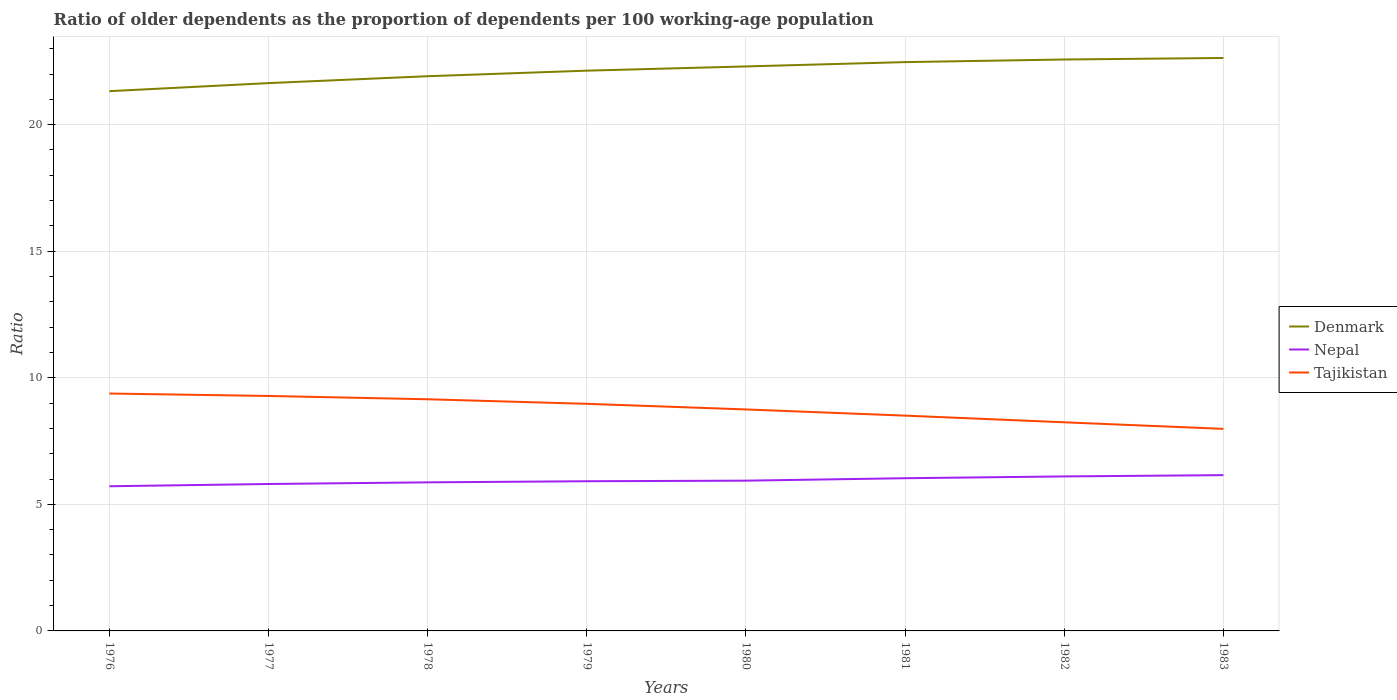How many different coloured lines are there?
Your answer should be very brief. 3. Across all years, what is the maximum age dependency ratio(old) in Denmark?
Give a very brief answer. 21.32. In which year was the age dependency ratio(old) in Nepal maximum?
Give a very brief answer. 1976. What is the total age dependency ratio(old) in Nepal in the graph?
Make the answer very short. -0.24. What is the difference between the highest and the second highest age dependency ratio(old) in Nepal?
Keep it short and to the point. 0.44. What is the difference between the highest and the lowest age dependency ratio(old) in Denmark?
Provide a short and direct response. 5. What is the difference between two consecutive major ticks on the Y-axis?
Make the answer very short. 5. Does the graph contain any zero values?
Your answer should be compact. No. Does the graph contain grids?
Keep it short and to the point. Yes. How many legend labels are there?
Your answer should be compact. 3. How are the legend labels stacked?
Provide a short and direct response. Vertical. What is the title of the graph?
Make the answer very short. Ratio of older dependents as the proportion of dependents per 100 working-age population. What is the label or title of the X-axis?
Offer a very short reply. Years. What is the label or title of the Y-axis?
Offer a very short reply. Ratio. What is the Ratio in Denmark in 1976?
Your answer should be very brief. 21.32. What is the Ratio in Nepal in 1976?
Offer a terse response. 5.72. What is the Ratio of Tajikistan in 1976?
Make the answer very short. 9.38. What is the Ratio of Denmark in 1977?
Ensure brevity in your answer.  21.64. What is the Ratio in Nepal in 1977?
Your answer should be compact. 5.8. What is the Ratio in Tajikistan in 1977?
Provide a short and direct response. 9.28. What is the Ratio in Denmark in 1978?
Provide a short and direct response. 21.91. What is the Ratio of Nepal in 1978?
Ensure brevity in your answer.  5.87. What is the Ratio of Tajikistan in 1978?
Make the answer very short. 9.15. What is the Ratio of Denmark in 1979?
Your response must be concise. 22.13. What is the Ratio of Nepal in 1979?
Give a very brief answer. 5.91. What is the Ratio in Tajikistan in 1979?
Provide a succinct answer. 8.97. What is the Ratio of Denmark in 1980?
Make the answer very short. 22.3. What is the Ratio of Nepal in 1980?
Make the answer very short. 5.94. What is the Ratio of Tajikistan in 1980?
Give a very brief answer. 8.75. What is the Ratio of Denmark in 1981?
Provide a short and direct response. 22.47. What is the Ratio of Nepal in 1981?
Ensure brevity in your answer.  6.03. What is the Ratio of Tajikistan in 1981?
Offer a terse response. 8.51. What is the Ratio of Denmark in 1982?
Provide a short and direct response. 22.57. What is the Ratio of Nepal in 1982?
Your answer should be compact. 6.1. What is the Ratio in Tajikistan in 1982?
Keep it short and to the point. 8.24. What is the Ratio in Denmark in 1983?
Make the answer very short. 22.63. What is the Ratio in Nepal in 1983?
Your response must be concise. 6.15. What is the Ratio in Tajikistan in 1983?
Offer a terse response. 7.98. Across all years, what is the maximum Ratio of Denmark?
Provide a succinct answer. 22.63. Across all years, what is the maximum Ratio in Nepal?
Give a very brief answer. 6.15. Across all years, what is the maximum Ratio in Tajikistan?
Offer a very short reply. 9.38. Across all years, what is the minimum Ratio in Denmark?
Offer a terse response. 21.32. Across all years, what is the minimum Ratio of Nepal?
Offer a very short reply. 5.72. Across all years, what is the minimum Ratio in Tajikistan?
Ensure brevity in your answer.  7.98. What is the total Ratio in Denmark in the graph?
Your answer should be compact. 176.99. What is the total Ratio in Nepal in the graph?
Keep it short and to the point. 47.53. What is the total Ratio in Tajikistan in the graph?
Make the answer very short. 70.26. What is the difference between the Ratio in Denmark in 1976 and that in 1977?
Give a very brief answer. -0.32. What is the difference between the Ratio in Nepal in 1976 and that in 1977?
Keep it short and to the point. -0.09. What is the difference between the Ratio of Tajikistan in 1976 and that in 1977?
Make the answer very short. 0.1. What is the difference between the Ratio of Denmark in 1976 and that in 1978?
Provide a succinct answer. -0.59. What is the difference between the Ratio in Nepal in 1976 and that in 1978?
Your answer should be very brief. -0.15. What is the difference between the Ratio in Tajikistan in 1976 and that in 1978?
Provide a short and direct response. 0.23. What is the difference between the Ratio in Denmark in 1976 and that in 1979?
Give a very brief answer. -0.81. What is the difference between the Ratio of Nepal in 1976 and that in 1979?
Offer a terse response. -0.2. What is the difference between the Ratio of Tajikistan in 1976 and that in 1979?
Offer a terse response. 0.41. What is the difference between the Ratio of Denmark in 1976 and that in 1980?
Keep it short and to the point. -0.98. What is the difference between the Ratio in Nepal in 1976 and that in 1980?
Give a very brief answer. -0.22. What is the difference between the Ratio in Tajikistan in 1976 and that in 1980?
Make the answer very short. 0.63. What is the difference between the Ratio in Denmark in 1976 and that in 1981?
Your answer should be very brief. -1.15. What is the difference between the Ratio of Nepal in 1976 and that in 1981?
Give a very brief answer. -0.32. What is the difference between the Ratio of Tajikistan in 1976 and that in 1981?
Provide a succinct answer. 0.87. What is the difference between the Ratio of Denmark in 1976 and that in 1982?
Your answer should be very brief. -1.25. What is the difference between the Ratio in Nepal in 1976 and that in 1982?
Provide a succinct answer. -0.39. What is the difference between the Ratio in Tajikistan in 1976 and that in 1982?
Provide a short and direct response. 1.14. What is the difference between the Ratio of Denmark in 1976 and that in 1983?
Your answer should be very brief. -1.31. What is the difference between the Ratio of Nepal in 1976 and that in 1983?
Ensure brevity in your answer.  -0.44. What is the difference between the Ratio of Tajikistan in 1976 and that in 1983?
Provide a short and direct response. 1.4. What is the difference between the Ratio of Denmark in 1977 and that in 1978?
Provide a succinct answer. -0.27. What is the difference between the Ratio in Nepal in 1977 and that in 1978?
Your answer should be very brief. -0.07. What is the difference between the Ratio in Tajikistan in 1977 and that in 1978?
Your answer should be very brief. 0.13. What is the difference between the Ratio in Denmark in 1977 and that in 1979?
Keep it short and to the point. -0.49. What is the difference between the Ratio of Nepal in 1977 and that in 1979?
Provide a succinct answer. -0.11. What is the difference between the Ratio of Tajikistan in 1977 and that in 1979?
Your answer should be compact. 0.31. What is the difference between the Ratio of Denmark in 1977 and that in 1980?
Provide a succinct answer. -0.66. What is the difference between the Ratio of Nepal in 1977 and that in 1980?
Your answer should be compact. -0.13. What is the difference between the Ratio of Tajikistan in 1977 and that in 1980?
Offer a very short reply. 0.53. What is the difference between the Ratio of Denmark in 1977 and that in 1981?
Offer a very short reply. -0.83. What is the difference between the Ratio of Nepal in 1977 and that in 1981?
Give a very brief answer. -0.23. What is the difference between the Ratio of Tajikistan in 1977 and that in 1981?
Ensure brevity in your answer.  0.78. What is the difference between the Ratio of Denmark in 1977 and that in 1982?
Your answer should be very brief. -0.93. What is the difference between the Ratio of Nepal in 1977 and that in 1982?
Provide a short and direct response. -0.3. What is the difference between the Ratio of Tajikistan in 1977 and that in 1982?
Your answer should be very brief. 1.04. What is the difference between the Ratio in Denmark in 1977 and that in 1983?
Provide a succinct answer. -0.99. What is the difference between the Ratio in Nepal in 1977 and that in 1983?
Give a very brief answer. -0.35. What is the difference between the Ratio in Tajikistan in 1977 and that in 1983?
Provide a succinct answer. 1.3. What is the difference between the Ratio in Denmark in 1978 and that in 1979?
Make the answer very short. -0.22. What is the difference between the Ratio of Nepal in 1978 and that in 1979?
Your response must be concise. -0.04. What is the difference between the Ratio in Tajikistan in 1978 and that in 1979?
Provide a succinct answer. 0.18. What is the difference between the Ratio in Denmark in 1978 and that in 1980?
Give a very brief answer. -0.39. What is the difference between the Ratio of Nepal in 1978 and that in 1980?
Provide a short and direct response. -0.07. What is the difference between the Ratio in Tajikistan in 1978 and that in 1980?
Provide a succinct answer. 0.4. What is the difference between the Ratio in Denmark in 1978 and that in 1981?
Keep it short and to the point. -0.56. What is the difference between the Ratio in Nepal in 1978 and that in 1981?
Keep it short and to the point. -0.16. What is the difference between the Ratio of Tajikistan in 1978 and that in 1981?
Make the answer very short. 0.65. What is the difference between the Ratio of Denmark in 1978 and that in 1982?
Ensure brevity in your answer.  -0.66. What is the difference between the Ratio in Nepal in 1978 and that in 1982?
Your answer should be very brief. -0.23. What is the difference between the Ratio of Tajikistan in 1978 and that in 1982?
Ensure brevity in your answer.  0.91. What is the difference between the Ratio in Denmark in 1978 and that in 1983?
Your answer should be compact. -0.72. What is the difference between the Ratio of Nepal in 1978 and that in 1983?
Keep it short and to the point. -0.28. What is the difference between the Ratio in Tajikistan in 1978 and that in 1983?
Provide a short and direct response. 1.17. What is the difference between the Ratio in Denmark in 1979 and that in 1980?
Give a very brief answer. -0.17. What is the difference between the Ratio in Nepal in 1979 and that in 1980?
Ensure brevity in your answer.  -0.02. What is the difference between the Ratio of Tajikistan in 1979 and that in 1980?
Offer a very short reply. 0.22. What is the difference between the Ratio in Denmark in 1979 and that in 1981?
Give a very brief answer. -0.34. What is the difference between the Ratio of Nepal in 1979 and that in 1981?
Your response must be concise. -0.12. What is the difference between the Ratio in Tajikistan in 1979 and that in 1981?
Offer a terse response. 0.47. What is the difference between the Ratio of Denmark in 1979 and that in 1982?
Offer a very short reply. -0.44. What is the difference between the Ratio in Nepal in 1979 and that in 1982?
Ensure brevity in your answer.  -0.19. What is the difference between the Ratio in Tajikistan in 1979 and that in 1982?
Offer a very short reply. 0.73. What is the difference between the Ratio of Denmark in 1979 and that in 1983?
Your answer should be very brief. -0.5. What is the difference between the Ratio of Nepal in 1979 and that in 1983?
Provide a short and direct response. -0.24. What is the difference between the Ratio of Tajikistan in 1979 and that in 1983?
Ensure brevity in your answer.  0.99. What is the difference between the Ratio of Denmark in 1980 and that in 1981?
Your response must be concise. -0.17. What is the difference between the Ratio in Nepal in 1980 and that in 1981?
Provide a succinct answer. -0.1. What is the difference between the Ratio in Tajikistan in 1980 and that in 1981?
Provide a short and direct response. 0.24. What is the difference between the Ratio of Denmark in 1980 and that in 1982?
Provide a succinct answer. -0.27. What is the difference between the Ratio of Nepal in 1980 and that in 1982?
Your response must be concise. -0.17. What is the difference between the Ratio of Tajikistan in 1980 and that in 1982?
Ensure brevity in your answer.  0.51. What is the difference between the Ratio in Denmark in 1980 and that in 1983?
Your response must be concise. -0.33. What is the difference between the Ratio in Nepal in 1980 and that in 1983?
Your answer should be very brief. -0.22. What is the difference between the Ratio of Tajikistan in 1980 and that in 1983?
Offer a very short reply. 0.77. What is the difference between the Ratio of Denmark in 1981 and that in 1982?
Provide a succinct answer. -0.1. What is the difference between the Ratio in Nepal in 1981 and that in 1982?
Make the answer very short. -0.07. What is the difference between the Ratio in Tajikistan in 1981 and that in 1982?
Ensure brevity in your answer.  0.26. What is the difference between the Ratio in Denmark in 1981 and that in 1983?
Keep it short and to the point. -0.16. What is the difference between the Ratio in Nepal in 1981 and that in 1983?
Provide a succinct answer. -0.12. What is the difference between the Ratio in Tajikistan in 1981 and that in 1983?
Provide a short and direct response. 0.52. What is the difference between the Ratio of Denmark in 1982 and that in 1983?
Provide a short and direct response. -0.06. What is the difference between the Ratio of Nepal in 1982 and that in 1983?
Make the answer very short. -0.05. What is the difference between the Ratio in Tajikistan in 1982 and that in 1983?
Your answer should be very brief. 0.26. What is the difference between the Ratio of Denmark in 1976 and the Ratio of Nepal in 1977?
Give a very brief answer. 15.52. What is the difference between the Ratio of Denmark in 1976 and the Ratio of Tajikistan in 1977?
Ensure brevity in your answer.  12.04. What is the difference between the Ratio of Nepal in 1976 and the Ratio of Tajikistan in 1977?
Provide a succinct answer. -3.57. What is the difference between the Ratio in Denmark in 1976 and the Ratio in Nepal in 1978?
Give a very brief answer. 15.45. What is the difference between the Ratio of Denmark in 1976 and the Ratio of Tajikistan in 1978?
Offer a very short reply. 12.17. What is the difference between the Ratio of Nepal in 1976 and the Ratio of Tajikistan in 1978?
Your answer should be compact. -3.44. What is the difference between the Ratio in Denmark in 1976 and the Ratio in Nepal in 1979?
Keep it short and to the point. 15.41. What is the difference between the Ratio of Denmark in 1976 and the Ratio of Tajikistan in 1979?
Your answer should be very brief. 12.35. What is the difference between the Ratio of Nepal in 1976 and the Ratio of Tajikistan in 1979?
Keep it short and to the point. -3.26. What is the difference between the Ratio in Denmark in 1976 and the Ratio in Nepal in 1980?
Your response must be concise. 15.39. What is the difference between the Ratio in Denmark in 1976 and the Ratio in Tajikistan in 1980?
Your response must be concise. 12.57. What is the difference between the Ratio of Nepal in 1976 and the Ratio of Tajikistan in 1980?
Keep it short and to the point. -3.03. What is the difference between the Ratio of Denmark in 1976 and the Ratio of Nepal in 1981?
Make the answer very short. 15.29. What is the difference between the Ratio in Denmark in 1976 and the Ratio in Tajikistan in 1981?
Keep it short and to the point. 12.82. What is the difference between the Ratio of Nepal in 1976 and the Ratio of Tajikistan in 1981?
Give a very brief answer. -2.79. What is the difference between the Ratio of Denmark in 1976 and the Ratio of Nepal in 1982?
Give a very brief answer. 15.22. What is the difference between the Ratio in Denmark in 1976 and the Ratio in Tajikistan in 1982?
Make the answer very short. 13.08. What is the difference between the Ratio of Nepal in 1976 and the Ratio of Tajikistan in 1982?
Provide a short and direct response. -2.53. What is the difference between the Ratio in Denmark in 1976 and the Ratio in Nepal in 1983?
Your answer should be compact. 15.17. What is the difference between the Ratio of Denmark in 1976 and the Ratio of Tajikistan in 1983?
Your answer should be very brief. 13.34. What is the difference between the Ratio of Nepal in 1976 and the Ratio of Tajikistan in 1983?
Offer a terse response. -2.27. What is the difference between the Ratio of Denmark in 1977 and the Ratio of Nepal in 1978?
Your response must be concise. 15.77. What is the difference between the Ratio of Denmark in 1977 and the Ratio of Tajikistan in 1978?
Keep it short and to the point. 12.49. What is the difference between the Ratio of Nepal in 1977 and the Ratio of Tajikistan in 1978?
Offer a very short reply. -3.35. What is the difference between the Ratio in Denmark in 1977 and the Ratio in Nepal in 1979?
Your answer should be very brief. 15.73. What is the difference between the Ratio in Denmark in 1977 and the Ratio in Tajikistan in 1979?
Offer a very short reply. 12.67. What is the difference between the Ratio of Nepal in 1977 and the Ratio of Tajikistan in 1979?
Provide a succinct answer. -3.17. What is the difference between the Ratio of Denmark in 1977 and the Ratio of Nepal in 1980?
Give a very brief answer. 15.71. What is the difference between the Ratio of Denmark in 1977 and the Ratio of Tajikistan in 1980?
Your answer should be compact. 12.89. What is the difference between the Ratio in Nepal in 1977 and the Ratio in Tajikistan in 1980?
Make the answer very short. -2.95. What is the difference between the Ratio in Denmark in 1977 and the Ratio in Nepal in 1981?
Your response must be concise. 15.61. What is the difference between the Ratio of Denmark in 1977 and the Ratio of Tajikistan in 1981?
Make the answer very short. 13.14. What is the difference between the Ratio of Nepal in 1977 and the Ratio of Tajikistan in 1981?
Make the answer very short. -2.7. What is the difference between the Ratio in Denmark in 1977 and the Ratio in Nepal in 1982?
Offer a very short reply. 15.54. What is the difference between the Ratio in Denmark in 1977 and the Ratio in Tajikistan in 1982?
Your answer should be compact. 13.4. What is the difference between the Ratio of Nepal in 1977 and the Ratio of Tajikistan in 1982?
Offer a very short reply. -2.44. What is the difference between the Ratio of Denmark in 1977 and the Ratio of Nepal in 1983?
Provide a short and direct response. 15.49. What is the difference between the Ratio of Denmark in 1977 and the Ratio of Tajikistan in 1983?
Your answer should be compact. 13.66. What is the difference between the Ratio in Nepal in 1977 and the Ratio in Tajikistan in 1983?
Keep it short and to the point. -2.18. What is the difference between the Ratio in Denmark in 1978 and the Ratio in Nepal in 1979?
Your answer should be very brief. 16. What is the difference between the Ratio in Denmark in 1978 and the Ratio in Tajikistan in 1979?
Give a very brief answer. 12.94. What is the difference between the Ratio of Nepal in 1978 and the Ratio of Tajikistan in 1979?
Ensure brevity in your answer.  -3.1. What is the difference between the Ratio of Denmark in 1978 and the Ratio of Nepal in 1980?
Ensure brevity in your answer.  15.98. What is the difference between the Ratio in Denmark in 1978 and the Ratio in Tajikistan in 1980?
Offer a very short reply. 13.16. What is the difference between the Ratio in Nepal in 1978 and the Ratio in Tajikistan in 1980?
Provide a succinct answer. -2.88. What is the difference between the Ratio in Denmark in 1978 and the Ratio in Nepal in 1981?
Make the answer very short. 15.88. What is the difference between the Ratio in Denmark in 1978 and the Ratio in Tajikistan in 1981?
Offer a terse response. 13.41. What is the difference between the Ratio in Nepal in 1978 and the Ratio in Tajikistan in 1981?
Ensure brevity in your answer.  -2.64. What is the difference between the Ratio in Denmark in 1978 and the Ratio in Nepal in 1982?
Offer a terse response. 15.81. What is the difference between the Ratio in Denmark in 1978 and the Ratio in Tajikistan in 1982?
Offer a terse response. 13.67. What is the difference between the Ratio of Nepal in 1978 and the Ratio of Tajikistan in 1982?
Make the answer very short. -2.37. What is the difference between the Ratio in Denmark in 1978 and the Ratio in Nepal in 1983?
Ensure brevity in your answer.  15.76. What is the difference between the Ratio of Denmark in 1978 and the Ratio of Tajikistan in 1983?
Offer a terse response. 13.93. What is the difference between the Ratio in Nepal in 1978 and the Ratio in Tajikistan in 1983?
Ensure brevity in your answer.  -2.11. What is the difference between the Ratio in Denmark in 1979 and the Ratio in Nepal in 1980?
Your answer should be very brief. 16.2. What is the difference between the Ratio of Denmark in 1979 and the Ratio of Tajikistan in 1980?
Give a very brief answer. 13.38. What is the difference between the Ratio in Nepal in 1979 and the Ratio in Tajikistan in 1980?
Offer a very short reply. -2.84. What is the difference between the Ratio of Denmark in 1979 and the Ratio of Nepal in 1981?
Provide a short and direct response. 16.1. What is the difference between the Ratio in Denmark in 1979 and the Ratio in Tajikistan in 1981?
Provide a short and direct response. 13.63. What is the difference between the Ratio of Nepal in 1979 and the Ratio of Tajikistan in 1981?
Your answer should be very brief. -2.59. What is the difference between the Ratio in Denmark in 1979 and the Ratio in Nepal in 1982?
Provide a short and direct response. 16.03. What is the difference between the Ratio in Denmark in 1979 and the Ratio in Tajikistan in 1982?
Your answer should be compact. 13.89. What is the difference between the Ratio of Nepal in 1979 and the Ratio of Tajikistan in 1982?
Your answer should be very brief. -2.33. What is the difference between the Ratio of Denmark in 1979 and the Ratio of Nepal in 1983?
Keep it short and to the point. 15.98. What is the difference between the Ratio of Denmark in 1979 and the Ratio of Tajikistan in 1983?
Your response must be concise. 14.15. What is the difference between the Ratio of Nepal in 1979 and the Ratio of Tajikistan in 1983?
Offer a terse response. -2.07. What is the difference between the Ratio in Denmark in 1980 and the Ratio in Nepal in 1981?
Keep it short and to the point. 16.27. What is the difference between the Ratio of Denmark in 1980 and the Ratio of Tajikistan in 1981?
Offer a terse response. 13.79. What is the difference between the Ratio of Nepal in 1980 and the Ratio of Tajikistan in 1981?
Offer a very short reply. -2.57. What is the difference between the Ratio in Denmark in 1980 and the Ratio in Nepal in 1982?
Your answer should be compact. 16.2. What is the difference between the Ratio of Denmark in 1980 and the Ratio of Tajikistan in 1982?
Your answer should be compact. 14.06. What is the difference between the Ratio of Nepal in 1980 and the Ratio of Tajikistan in 1982?
Your response must be concise. -2.31. What is the difference between the Ratio in Denmark in 1980 and the Ratio in Nepal in 1983?
Your answer should be compact. 16.15. What is the difference between the Ratio of Denmark in 1980 and the Ratio of Tajikistan in 1983?
Your response must be concise. 14.32. What is the difference between the Ratio in Nepal in 1980 and the Ratio in Tajikistan in 1983?
Ensure brevity in your answer.  -2.05. What is the difference between the Ratio in Denmark in 1981 and the Ratio in Nepal in 1982?
Your response must be concise. 16.37. What is the difference between the Ratio in Denmark in 1981 and the Ratio in Tajikistan in 1982?
Ensure brevity in your answer.  14.23. What is the difference between the Ratio of Nepal in 1981 and the Ratio of Tajikistan in 1982?
Give a very brief answer. -2.21. What is the difference between the Ratio in Denmark in 1981 and the Ratio in Nepal in 1983?
Offer a terse response. 16.32. What is the difference between the Ratio in Denmark in 1981 and the Ratio in Tajikistan in 1983?
Provide a short and direct response. 14.49. What is the difference between the Ratio of Nepal in 1981 and the Ratio of Tajikistan in 1983?
Provide a short and direct response. -1.95. What is the difference between the Ratio of Denmark in 1982 and the Ratio of Nepal in 1983?
Your response must be concise. 16.42. What is the difference between the Ratio of Denmark in 1982 and the Ratio of Tajikistan in 1983?
Provide a succinct answer. 14.59. What is the difference between the Ratio of Nepal in 1982 and the Ratio of Tajikistan in 1983?
Keep it short and to the point. -1.88. What is the average Ratio in Denmark per year?
Provide a short and direct response. 22.12. What is the average Ratio of Nepal per year?
Make the answer very short. 5.94. What is the average Ratio in Tajikistan per year?
Offer a terse response. 8.78. In the year 1976, what is the difference between the Ratio of Denmark and Ratio of Nepal?
Ensure brevity in your answer.  15.61. In the year 1976, what is the difference between the Ratio of Denmark and Ratio of Tajikistan?
Give a very brief answer. 11.94. In the year 1976, what is the difference between the Ratio in Nepal and Ratio in Tajikistan?
Your answer should be compact. -3.66. In the year 1977, what is the difference between the Ratio in Denmark and Ratio in Nepal?
Ensure brevity in your answer.  15.84. In the year 1977, what is the difference between the Ratio of Denmark and Ratio of Tajikistan?
Your response must be concise. 12.36. In the year 1977, what is the difference between the Ratio in Nepal and Ratio in Tajikistan?
Give a very brief answer. -3.48. In the year 1978, what is the difference between the Ratio in Denmark and Ratio in Nepal?
Provide a short and direct response. 16.04. In the year 1978, what is the difference between the Ratio in Denmark and Ratio in Tajikistan?
Your answer should be very brief. 12.76. In the year 1978, what is the difference between the Ratio in Nepal and Ratio in Tajikistan?
Your answer should be compact. -3.28. In the year 1979, what is the difference between the Ratio of Denmark and Ratio of Nepal?
Offer a terse response. 16.22. In the year 1979, what is the difference between the Ratio in Denmark and Ratio in Tajikistan?
Your answer should be compact. 13.16. In the year 1979, what is the difference between the Ratio in Nepal and Ratio in Tajikistan?
Ensure brevity in your answer.  -3.06. In the year 1980, what is the difference between the Ratio in Denmark and Ratio in Nepal?
Make the answer very short. 16.36. In the year 1980, what is the difference between the Ratio in Denmark and Ratio in Tajikistan?
Offer a terse response. 13.55. In the year 1980, what is the difference between the Ratio in Nepal and Ratio in Tajikistan?
Your response must be concise. -2.81. In the year 1981, what is the difference between the Ratio of Denmark and Ratio of Nepal?
Provide a succinct answer. 16.44. In the year 1981, what is the difference between the Ratio in Denmark and Ratio in Tajikistan?
Your answer should be compact. 13.97. In the year 1981, what is the difference between the Ratio of Nepal and Ratio of Tajikistan?
Your answer should be compact. -2.47. In the year 1982, what is the difference between the Ratio in Denmark and Ratio in Nepal?
Offer a terse response. 16.47. In the year 1982, what is the difference between the Ratio of Denmark and Ratio of Tajikistan?
Ensure brevity in your answer.  14.33. In the year 1982, what is the difference between the Ratio in Nepal and Ratio in Tajikistan?
Your response must be concise. -2.14. In the year 1983, what is the difference between the Ratio in Denmark and Ratio in Nepal?
Keep it short and to the point. 16.48. In the year 1983, what is the difference between the Ratio in Denmark and Ratio in Tajikistan?
Your response must be concise. 14.65. In the year 1983, what is the difference between the Ratio in Nepal and Ratio in Tajikistan?
Give a very brief answer. -1.83. What is the ratio of the Ratio of Nepal in 1976 to that in 1977?
Give a very brief answer. 0.98. What is the ratio of the Ratio of Tajikistan in 1976 to that in 1977?
Offer a terse response. 1.01. What is the ratio of the Ratio in Denmark in 1976 to that in 1978?
Offer a very short reply. 0.97. What is the ratio of the Ratio in Nepal in 1976 to that in 1978?
Provide a short and direct response. 0.97. What is the ratio of the Ratio of Tajikistan in 1976 to that in 1978?
Your answer should be very brief. 1.02. What is the ratio of the Ratio in Denmark in 1976 to that in 1979?
Ensure brevity in your answer.  0.96. What is the ratio of the Ratio in Nepal in 1976 to that in 1979?
Provide a short and direct response. 0.97. What is the ratio of the Ratio of Tajikistan in 1976 to that in 1979?
Provide a short and direct response. 1.05. What is the ratio of the Ratio of Denmark in 1976 to that in 1980?
Provide a succinct answer. 0.96. What is the ratio of the Ratio of Nepal in 1976 to that in 1980?
Offer a very short reply. 0.96. What is the ratio of the Ratio of Tajikistan in 1976 to that in 1980?
Keep it short and to the point. 1.07. What is the ratio of the Ratio in Denmark in 1976 to that in 1981?
Make the answer very short. 0.95. What is the ratio of the Ratio in Nepal in 1976 to that in 1981?
Give a very brief answer. 0.95. What is the ratio of the Ratio of Tajikistan in 1976 to that in 1981?
Your response must be concise. 1.1. What is the ratio of the Ratio in Denmark in 1976 to that in 1982?
Make the answer very short. 0.94. What is the ratio of the Ratio in Nepal in 1976 to that in 1982?
Keep it short and to the point. 0.94. What is the ratio of the Ratio in Tajikistan in 1976 to that in 1982?
Provide a short and direct response. 1.14. What is the ratio of the Ratio in Denmark in 1976 to that in 1983?
Your answer should be compact. 0.94. What is the ratio of the Ratio in Nepal in 1976 to that in 1983?
Provide a short and direct response. 0.93. What is the ratio of the Ratio in Tajikistan in 1976 to that in 1983?
Give a very brief answer. 1.17. What is the ratio of the Ratio in Denmark in 1977 to that in 1978?
Keep it short and to the point. 0.99. What is the ratio of the Ratio of Tajikistan in 1977 to that in 1978?
Provide a succinct answer. 1.01. What is the ratio of the Ratio of Denmark in 1977 to that in 1979?
Your answer should be compact. 0.98. What is the ratio of the Ratio of Nepal in 1977 to that in 1979?
Ensure brevity in your answer.  0.98. What is the ratio of the Ratio in Tajikistan in 1977 to that in 1979?
Your answer should be compact. 1.03. What is the ratio of the Ratio of Denmark in 1977 to that in 1980?
Your answer should be very brief. 0.97. What is the ratio of the Ratio in Nepal in 1977 to that in 1980?
Ensure brevity in your answer.  0.98. What is the ratio of the Ratio in Tajikistan in 1977 to that in 1980?
Offer a very short reply. 1.06. What is the ratio of the Ratio in Denmark in 1977 to that in 1981?
Offer a terse response. 0.96. What is the ratio of the Ratio in Nepal in 1977 to that in 1981?
Your answer should be very brief. 0.96. What is the ratio of the Ratio of Tajikistan in 1977 to that in 1981?
Provide a succinct answer. 1.09. What is the ratio of the Ratio of Denmark in 1977 to that in 1982?
Offer a terse response. 0.96. What is the ratio of the Ratio in Nepal in 1977 to that in 1982?
Make the answer very short. 0.95. What is the ratio of the Ratio of Tajikistan in 1977 to that in 1982?
Provide a succinct answer. 1.13. What is the ratio of the Ratio in Denmark in 1977 to that in 1983?
Provide a short and direct response. 0.96. What is the ratio of the Ratio in Nepal in 1977 to that in 1983?
Provide a short and direct response. 0.94. What is the ratio of the Ratio in Tajikistan in 1977 to that in 1983?
Your answer should be compact. 1.16. What is the ratio of the Ratio of Denmark in 1978 to that in 1979?
Provide a succinct answer. 0.99. What is the ratio of the Ratio of Nepal in 1978 to that in 1979?
Provide a succinct answer. 0.99. What is the ratio of the Ratio in Denmark in 1978 to that in 1980?
Make the answer very short. 0.98. What is the ratio of the Ratio in Tajikistan in 1978 to that in 1980?
Your response must be concise. 1.05. What is the ratio of the Ratio of Denmark in 1978 to that in 1981?
Provide a short and direct response. 0.98. What is the ratio of the Ratio of Nepal in 1978 to that in 1981?
Offer a terse response. 0.97. What is the ratio of the Ratio in Tajikistan in 1978 to that in 1981?
Provide a succinct answer. 1.08. What is the ratio of the Ratio in Denmark in 1978 to that in 1982?
Make the answer very short. 0.97. What is the ratio of the Ratio of Nepal in 1978 to that in 1982?
Provide a short and direct response. 0.96. What is the ratio of the Ratio in Tajikistan in 1978 to that in 1982?
Keep it short and to the point. 1.11. What is the ratio of the Ratio in Denmark in 1978 to that in 1983?
Give a very brief answer. 0.97. What is the ratio of the Ratio in Nepal in 1978 to that in 1983?
Make the answer very short. 0.95. What is the ratio of the Ratio in Tajikistan in 1978 to that in 1983?
Your answer should be compact. 1.15. What is the ratio of the Ratio in Denmark in 1979 to that in 1980?
Provide a short and direct response. 0.99. What is the ratio of the Ratio of Nepal in 1979 to that in 1980?
Offer a very short reply. 1. What is the ratio of the Ratio in Tajikistan in 1979 to that in 1980?
Give a very brief answer. 1.03. What is the ratio of the Ratio in Nepal in 1979 to that in 1981?
Your response must be concise. 0.98. What is the ratio of the Ratio in Tajikistan in 1979 to that in 1981?
Provide a succinct answer. 1.05. What is the ratio of the Ratio in Denmark in 1979 to that in 1982?
Keep it short and to the point. 0.98. What is the ratio of the Ratio in Nepal in 1979 to that in 1982?
Your response must be concise. 0.97. What is the ratio of the Ratio of Tajikistan in 1979 to that in 1982?
Your answer should be very brief. 1.09. What is the ratio of the Ratio in Denmark in 1979 to that in 1983?
Offer a terse response. 0.98. What is the ratio of the Ratio in Nepal in 1979 to that in 1983?
Your answer should be very brief. 0.96. What is the ratio of the Ratio in Tajikistan in 1979 to that in 1983?
Keep it short and to the point. 1.12. What is the ratio of the Ratio in Nepal in 1980 to that in 1981?
Your answer should be very brief. 0.98. What is the ratio of the Ratio in Tajikistan in 1980 to that in 1981?
Your answer should be compact. 1.03. What is the ratio of the Ratio of Denmark in 1980 to that in 1982?
Ensure brevity in your answer.  0.99. What is the ratio of the Ratio in Nepal in 1980 to that in 1982?
Your response must be concise. 0.97. What is the ratio of the Ratio in Tajikistan in 1980 to that in 1982?
Keep it short and to the point. 1.06. What is the ratio of the Ratio of Denmark in 1980 to that in 1983?
Your response must be concise. 0.99. What is the ratio of the Ratio in Nepal in 1980 to that in 1983?
Provide a succinct answer. 0.96. What is the ratio of the Ratio in Tajikistan in 1980 to that in 1983?
Your response must be concise. 1.1. What is the ratio of the Ratio of Denmark in 1981 to that in 1982?
Make the answer very short. 1. What is the ratio of the Ratio of Nepal in 1981 to that in 1982?
Provide a succinct answer. 0.99. What is the ratio of the Ratio in Tajikistan in 1981 to that in 1982?
Your response must be concise. 1.03. What is the ratio of the Ratio of Nepal in 1981 to that in 1983?
Your answer should be very brief. 0.98. What is the ratio of the Ratio in Tajikistan in 1981 to that in 1983?
Give a very brief answer. 1.07. What is the ratio of the Ratio of Nepal in 1982 to that in 1983?
Ensure brevity in your answer.  0.99. What is the ratio of the Ratio of Tajikistan in 1982 to that in 1983?
Provide a succinct answer. 1.03. What is the difference between the highest and the second highest Ratio of Denmark?
Your answer should be compact. 0.06. What is the difference between the highest and the second highest Ratio in Nepal?
Offer a terse response. 0.05. What is the difference between the highest and the second highest Ratio in Tajikistan?
Provide a short and direct response. 0.1. What is the difference between the highest and the lowest Ratio in Denmark?
Offer a very short reply. 1.31. What is the difference between the highest and the lowest Ratio in Nepal?
Offer a very short reply. 0.44. What is the difference between the highest and the lowest Ratio of Tajikistan?
Offer a terse response. 1.4. 